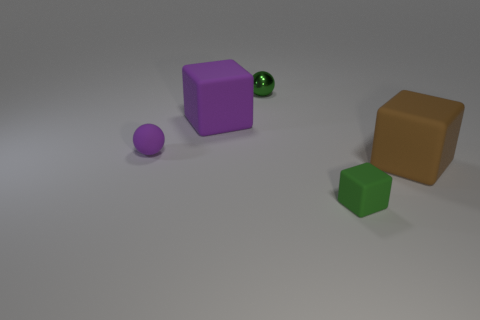What materials are the objects in the image made of, and what colors are they? The objects in the image appear to be made of two different materials based on their surfaces: rubber and metal. The rubber objects include a large purple cube and a small brown cube, as well as a small purple sphere. The metallic object is a small green sphere showing a reflective surface. The colors present in the assortment are purple, brown, and green. 